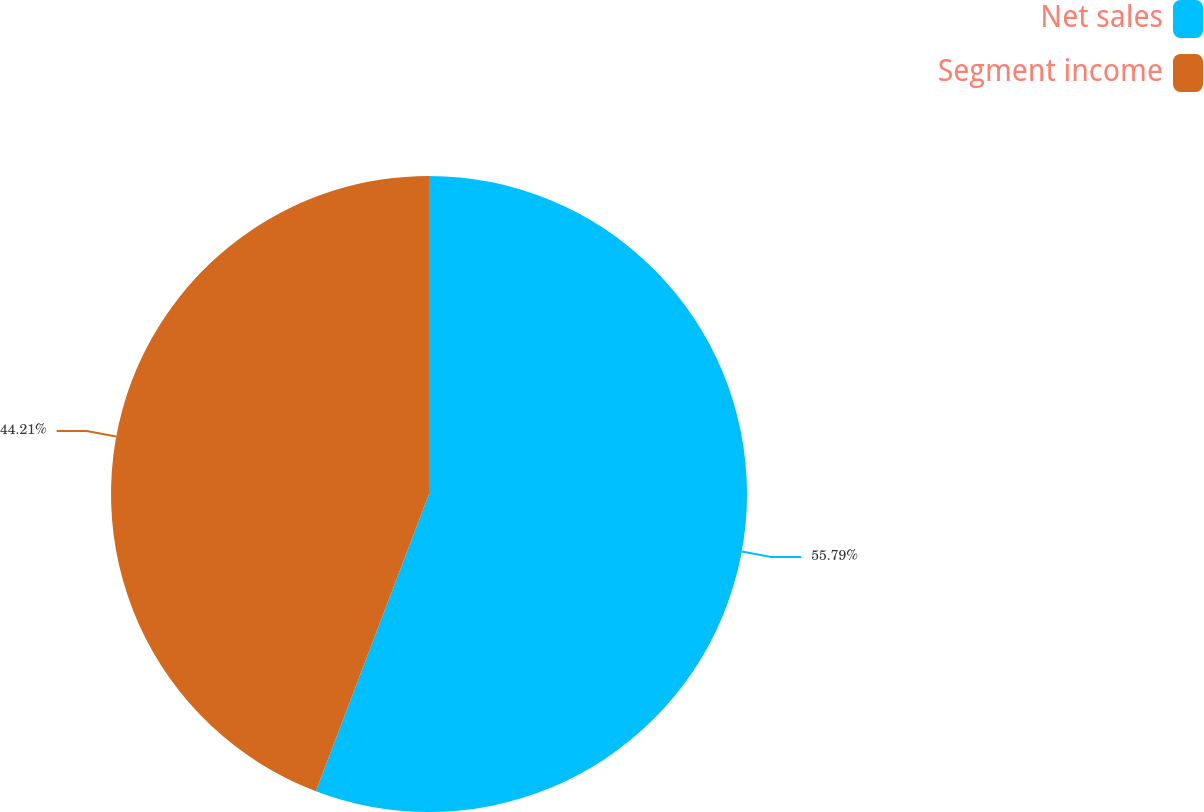Convert chart to OTSL. <chart><loc_0><loc_0><loc_500><loc_500><pie_chart><fcel>Net sales<fcel>Segment income<nl><fcel>55.79%<fcel>44.21%<nl></chart> 